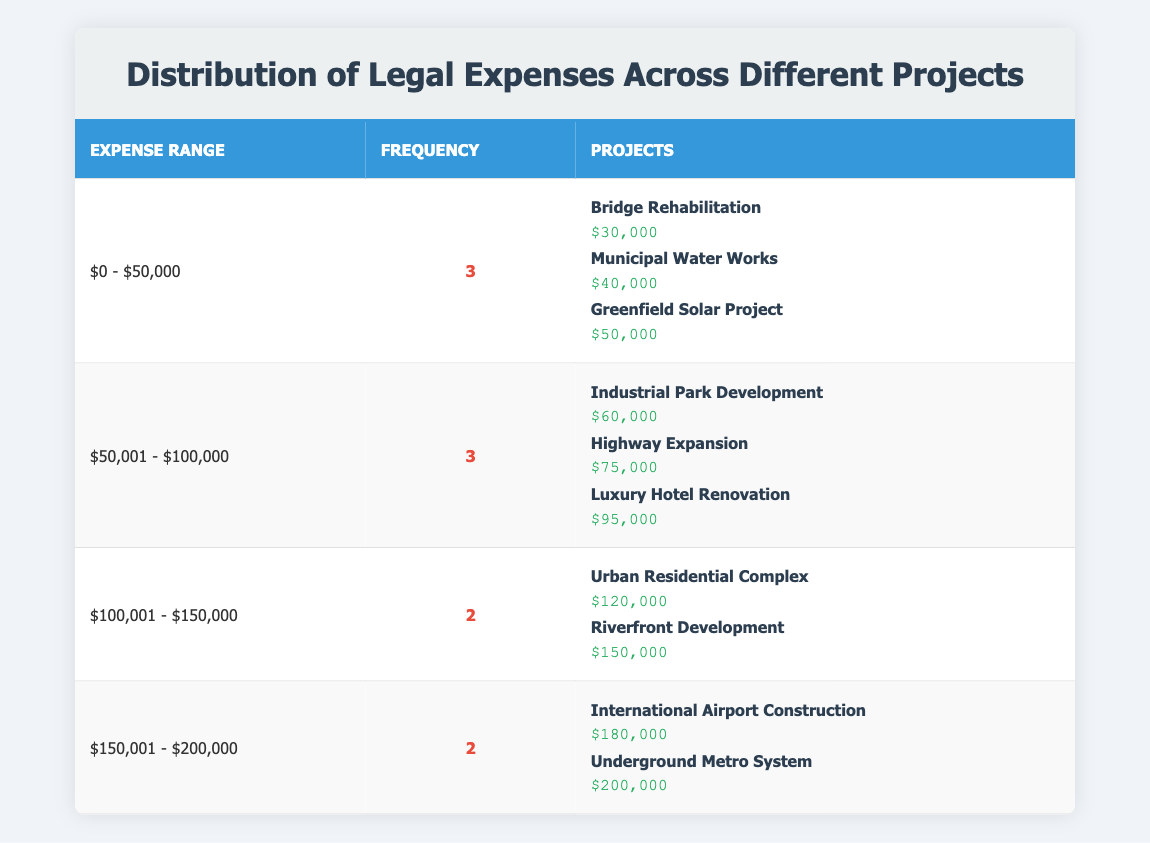What is the total number of projects that have legal expenses above $150,000? The table shows two categories: $150,001 - $200,000 and above, which list four projects. From these categories, we identify the projects: International Airport Construction and Underground Metro System are above $150,000, making a total of 4 projects with expenses higher than that amount.
Answer: 4 Which project incurred the highest legal expenses? Looking through the table, the project with the highest legal expenses is listed under the $150,001 - $200,000 range as the Underground Metro System, with expenses of $200,000.
Answer: $200,000 How many projects have legal expenses in the range of $50,001 - $100,000? The table shows that there are three projects listed within the $50,001 - $100,000 range: Industrial Park Development, Highway Expansion, and Luxury Hotel Renovation. Therefore, the number of projects in this category is three.
Answer: 3 Is there any project that has legal expenses equal to $40,000? The table lists a project, Municipal Water Works, with legal expenses specifically mentioned as $40,000. This confirms that yes, there is such a project.
Answer: Yes What is the average legal expense for projects in the range of $100,001 - $150,000? In this range, there are two projects: Urban Residential Complex ($120,000) and Riverfront Development ($150,000). The sum of these expenses is $270,000. To find the average, divide by the number of projects, which is 2. Hence, the average is $270,000 divided by 2 which equals $135,000.
Answer: $135,000 How many projects fall under legal expense categories of $0 - $50,000 and $150,001 - $200,000 combined? Counting the projects under the two selected ranges: there are 3 projects in the $0 - $50,000 range and 2 projects in the $150,001 - $200,000 range. The total projects in both ranges is 3 + 2 which equals 5.
Answer: 5 Which projects fall under the expense range of $150,001 - $200,000? There are two projects in this range: International Airport Construction with $180,000 and Underground Metro System with $200,000. Both projects are specified within that expense range.
Answer: International Airport Construction, Underground Metro System How many projects have legal expenses between $50,001 and $150,000? The table displays legal expenses in various ranges. Summing the projects in the ranges: $50,001 - $100,000 (3 projects) and $100,001 - $150,000 (2 projects) gives a total of 5 projects within this range.
Answer: 5 